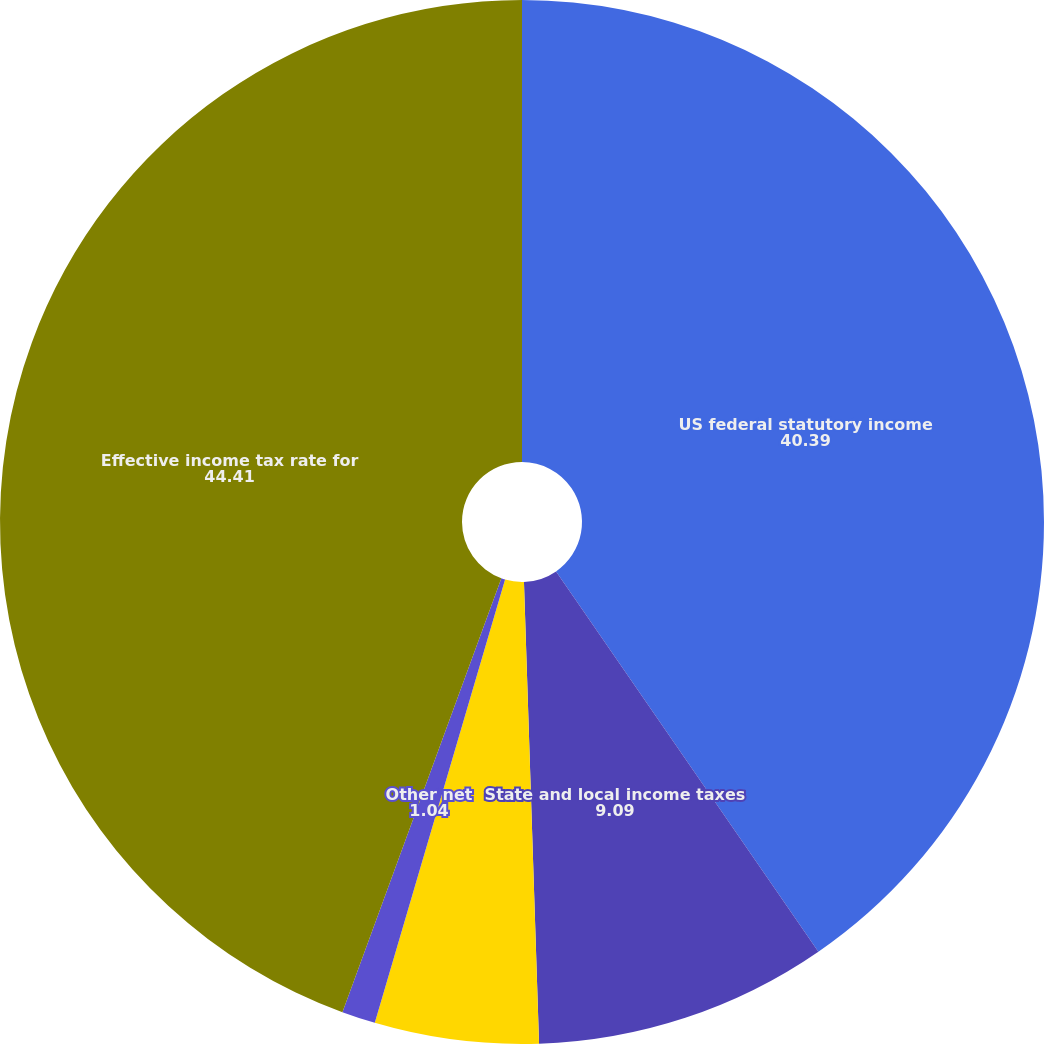Convert chart to OTSL. <chart><loc_0><loc_0><loc_500><loc_500><pie_chart><fcel>US federal statutory income<fcel>State and local income taxes<fcel>Foreign operations<fcel>Other net<fcel>Effective income tax rate for<nl><fcel>40.39%<fcel>9.09%<fcel>5.07%<fcel>1.04%<fcel>44.41%<nl></chart> 